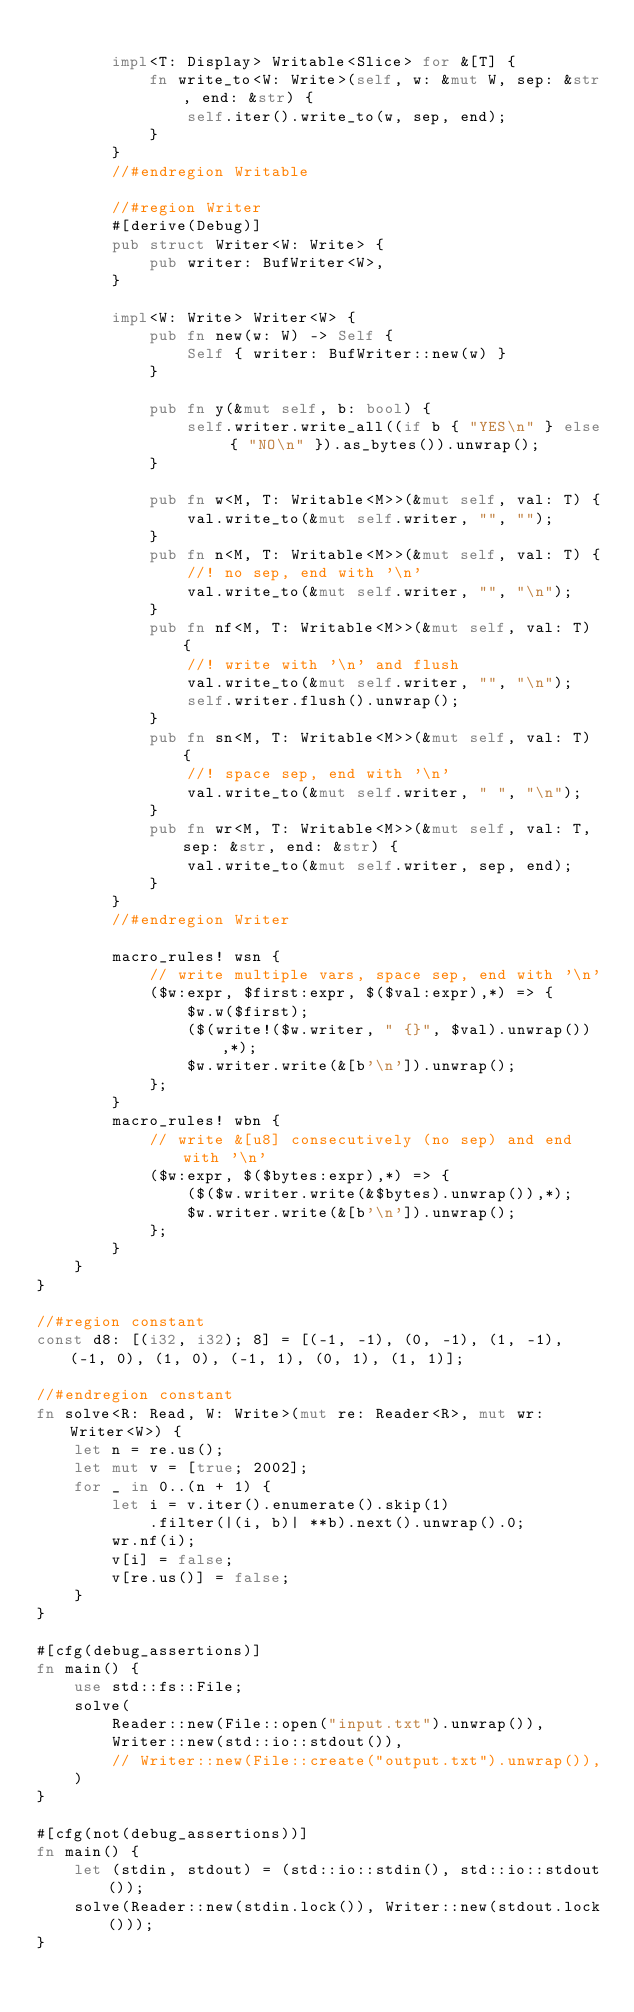Convert code to text. <code><loc_0><loc_0><loc_500><loc_500><_Rust_>
        impl<T: Display> Writable<Slice> for &[T] {
            fn write_to<W: Write>(self, w: &mut W, sep: &str, end: &str) {
                self.iter().write_to(w, sep, end);
            }
        }
        //#endregion Writable

        //#region Writer
        #[derive(Debug)]
        pub struct Writer<W: Write> {
            pub writer: BufWriter<W>,
        }

        impl<W: Write> Writer<W> {
            pub fn new(w: W) -> Self {
                Self { writer: BufWriter::new(w) }
            }

            pub fn y(&mut self, b: bool) {
                self.writer.write_all((if b { "YES\n" } else { "NO\n" }).as_bytes()).unwrap();
            }

            pub fn w<M, T: Writable<M>>(&mut self, val: T) {
                val.write_to(&mut self.writer, "", "");
            }
            pub fn n<M, T: Writable<M>>(&mut self, val: T) {
                //! no sep, end with '\n'
                val.write_to(&mut self.writer, "", "\n");
            }
            pub fn nf<M, T: Writable<M>>(&mut self, val: T) {
                //! write with '\n' and flush
                val.write_to(&mut self.writer, "", "\n");
                self.writer.flush().unwrap();
            }
            pub fn sn<M, T: Writable<M>>(&mut self, val: T) {
                //! space sep, end with '\n'
                val.write_to(&mut self.writer, " ", "\n");
            }
            pub fn wr<M, T: Writable<M>>(&mut self, val: T, sep: &str, end: &str) {
                val.write_to(&mut self.writer, sep, end);
            }
        }
        //#endregion Writer

        macro_rules! wsn {
            // write multiple vars, space sep, end with '\n'
            ($w:expr, $first:expr, $($val:expr),*) => {
                $w.w($first);
                ($(write!($w.writer, " {}", $val).unwrap()),*);
                $w.writer.write(&[b'\n']).unwrap();
            };
        }
        macro_rules! wbn {
            // write &[u8] consecutively (no sep) and end with '\n'
            ($w:expr, $($bytes:expr),*) => {
                ($($w.writer.write(&$bytes).unwrap()),*);
                $w.writer.write(&[b'\n']).unwrap();
            };
        }
    }
}

//#region constant
const d8: [(i32, i32); 8] = [(-1, -1), (0, -1), (1, -1), (-1, 0), (1, 0), (-1, 1), (0, 1), (1, 1)];

//#endregion constant
fn solve<R: Read, W: Write>(mut re: Reader<R>, mut wr: Writer<W>) {
    let n = re.us();
    let mut v = [true; 2002];
    for _ in 0..(n + 1) {
        let i = v.iter().enumerate().skip(1)
            .filter(|(i, b)| **b).next().unwrap().0;
        wr.nf(i);
        v[i] = false;
        v[re.us()] = false;
    }
}

#[cfg(debug_assertions)]
fn main() {
    use std::fs::File;
    solve(
        Reader::new(File::open("input.txt").unwrap()),
        Writer::new(std::io::stdout()),
        // Writer::new(File::create("output.txt").unwrap()),
    )
}

#[cfg(not(debug_assertions))]
fn main() {
    let (stdin, stdout) = (std::io::stdin(), std::io::stdout());
    solve(Reader::new(stdin.lock()), Writer::new(stdout.lock()));
}
</code> 